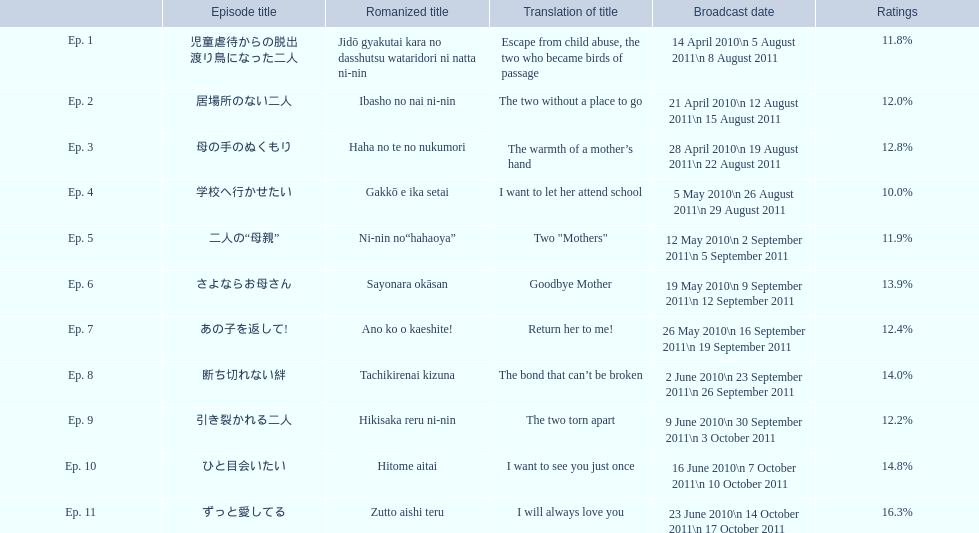What are all of the episode numbers? Ep. 1, Ep. 2, Ep. 3, Ep. 4, Ep. 5, Ep. 6, Ep. 7, Ep. 8, Ep. 9, Ep. 10, Ep. 11. And their titles? 児童虐待からの脱出 渡り鳥になった二人, 居場所のない二人, 母の手のぬくもり, 学校へ行かせたい, 二人の“母親”, さよならお母さん, あの子を返して!, 断ち切れない絆, 引き裂かれる二人, ひと目会いたい, ずっと愛してる. What about their translated names? Escape from child abuse, the two who became birds of passage, The two without a place to go, The warmth of a mother’s hand, I want to let her attend school, Two "Mothers", Goodbye Mother, Return her to me!, The bond that can’t be broken, The two torn apart, I want to see you just once, I will always love you. Which episode number's title translated to i want to let her attend school? Ep. 4. 